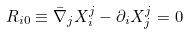Convert formula to latex. <formula><loc_0><loc_0><loc_500><loc_500>R _ { i 0 } \equiv \bar { \nabla } _ { j } X _ { i } ^ { j } - \partial _ { i } X _ { j } ^ { j } = 0</formula> 